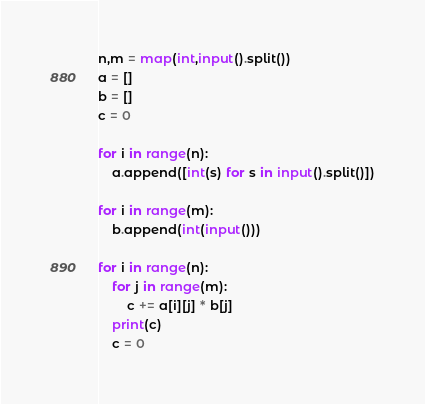Convert code to text. <code><loc_0><loc_0><loc_500><loc_500><_Python_>n,m = map(int,input().split())
a = []
b = []
c = 0

for i in range(n):
    a.append([int(s) for s in input().split()])

for i in range(m):
    b.append(int(input()))

for i in range(n):
    for j in range(m):
        c += a[i][j] * b[j]
    print(c)
    c = 0

</code> 